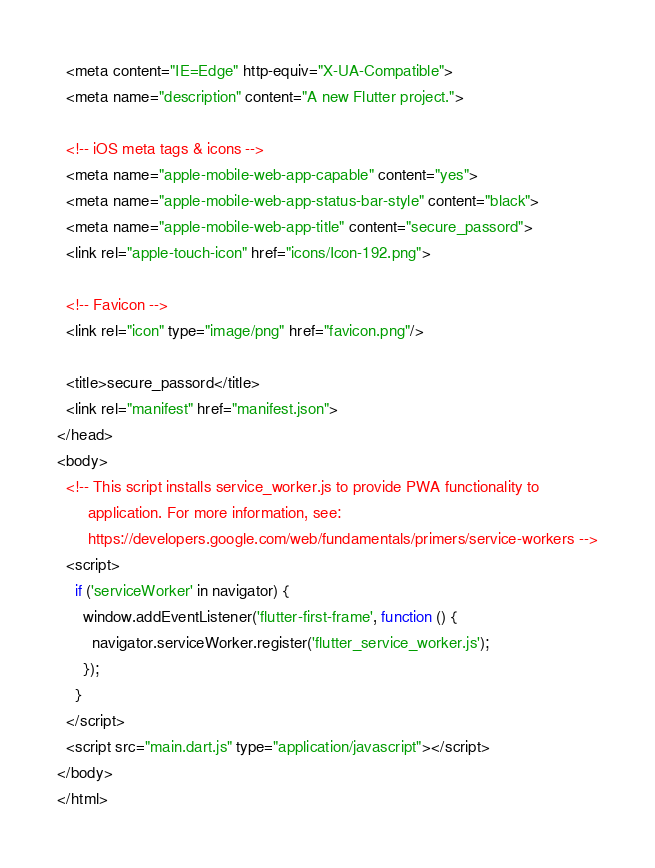<code> <loc_0><loc_0><loc_500><loc_500><_HTML_>  <meta content="IE=Edge" http-equiv="X-UA-Compatible">
  <meta name="description" content="A new Flutter project.">

  <!-- iOS meta tags & icons -->
  <meta name="apple-mobile-web-app-capable" content="yes">
  <meta name="apple-mobile-web-app-status-bar-style" content="black">
  <meta name="apple-mobile-web-app-title" content="secure_passord">
  <link rel="apple-touch-icon" href="icons/Icon-192.png">

  <!-- Favicon -->
  <link rel="icon" type="image/png" href="favicon.png"/>

  <title>secure_passord</title>
  <link rel="manifest" href="manifest.json">
</head>
<body>
  <!-- This script installs service_worker.js to provide PWA functionality to
       application. For more information, see:
       https://developers.google.com/web/fundamentals/primers/service-workers -->
  <script>
    if ('serviceWorker' in navigator) {
      window.addEventListener('flutter-first-frame', function () {
        navigator.serviceWorker.register('flutter_service_worker.js');
      });
    }
  </script>
  <script src="main.dart.js" type="application/javascript"></script>
</body>
</html>
</code> 